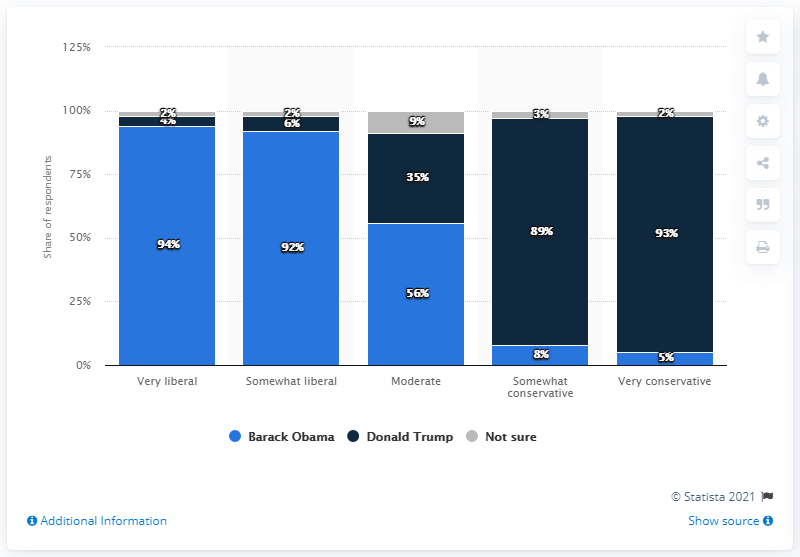Point out several critical features in this image. In February 2017, Donald Trump was the President of the United States. 